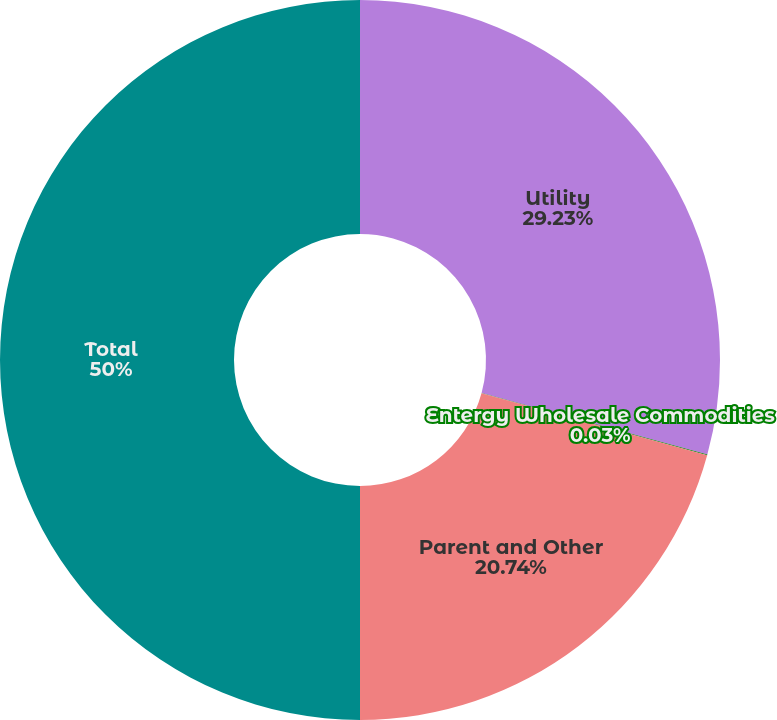<chart> <loc_0><loc_0><loc_500><loc_500><pie_chart><fcel>Utility<fcel>Entergy Wholesale Commodities<fcel>Parent and Other<fcel>Total<nl><fcel>29.23%<fcel>0.03%<fcel>20.74%<fcel>50.0%<nl></chart> 